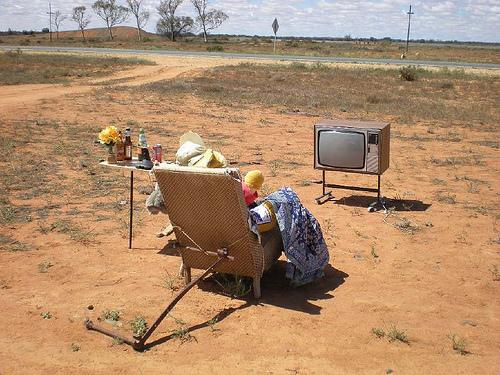What's connected to the back of the chair?

Choices:
A) blanket
B) metal rod
C) ribbon
D) tv metal rod 